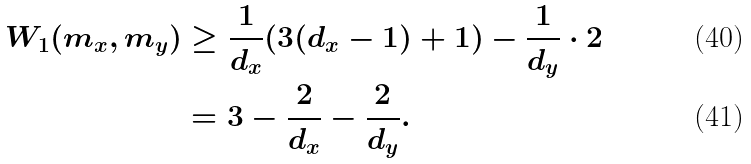<formula> <loc_0><loc_0><loc_500><loc_500>W _ { 1 } ( m _ { x } , m _ { y } ) & \geq \frac { 1 } { d _ { x } } ( 3 ( d _ { x } - 1 ) + 1 ) - \frac { 1 } { d _ { y } } \cdot 2 \\ & = 3 - \frac { 2 } { d _ { x } } - \frac { 2 } { d _ { y } } .</formula> 